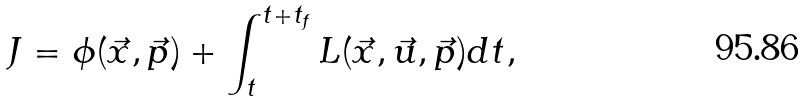Convert formula to latex. <formula><loc_0><loc_0><loc_500><loc_500>J = \phi ( \vec { x } , \vec { p } ) + \int _ { t } ^ { t + t _ { f } } L ( \vec { x } , \vec { u } , \vec { p } ) d t ,</formula> 